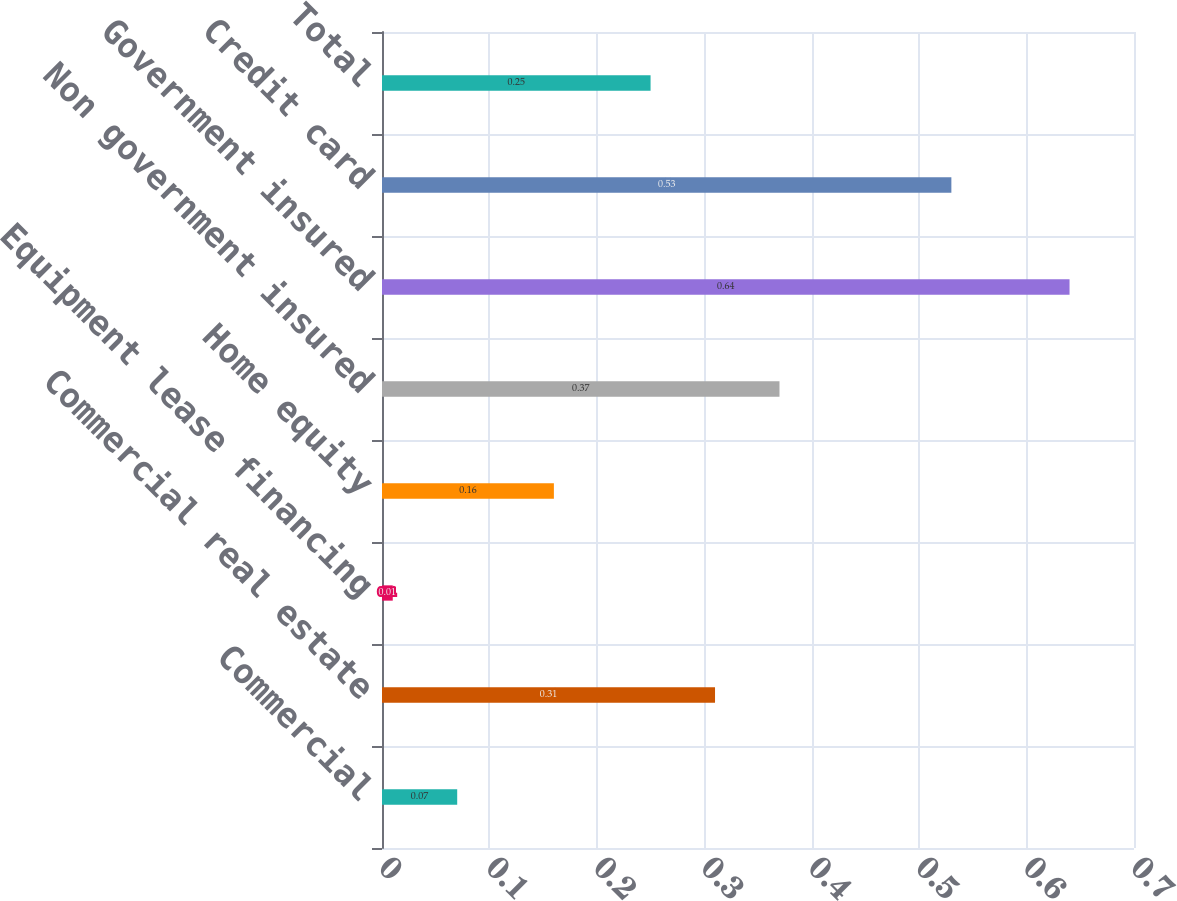Convert chart to OTSL. <chart><loc_0><loc_0><loc_500><loc_500><bar_chart><fcel>Commercial<fcel>Commercial real estate<fcel>Equipment lease financing<fcel>Home equity<fcel>Non government insured<fcel>Government insured<fcel>Credit card<fcel>Total<nl><fcel>0.07<fcel>0.31<fcel>0.01<fcel>0.16<fcel>0.37<fcel>0.64<fcel>0.53<fcel>0.25<nl></chart> 